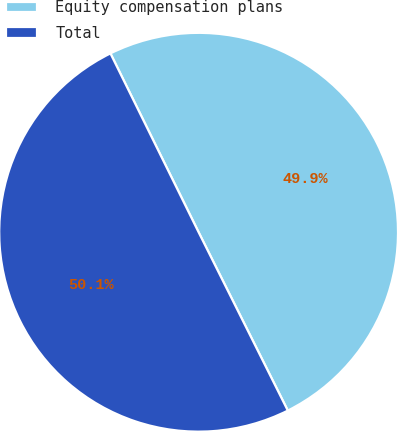<chart> <loc_0><loc_0><loc_500><loc_500><pie_chart><fcel>Equity compensation plans<fcel>Total<nl><fcel>49.91%<fcel>50.09%<nl></chart> 